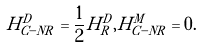<formula> <loc_0><loc_0><loc_500><loc_500>H ^ { D } _ { C - N R } = \frac { 1 } { 2 } H ^ { D } _ { R } , H ^ { M } _ { C - N R } = 0 .</formula> 